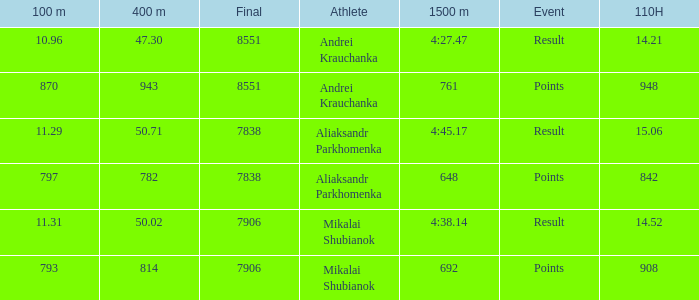Parse the table in full. {'header': ['100 m', '400 m', 'Final', 'Athlete', '1500 m', 'Event', '110H'], 'rows': [['10.96', '47.30', '8551', 'Andrei Krauchanka', '4:27.47', 'Result', '14.21'], ['870', '943', '8551', 'Andrei Krauchanka', '761', 'Points', '948'], ['11.29', '50.71', '7838', 'Aliaksandr Parkhomenka', '4:45.17', 'Result', '15.06'], ['797', '782', '7838', 'Aliaksandr Parkhomenka', '648', 'Points', '842'], ['11.31', '50.02', '7906', 'Mikalai Shubianok', '4:38.14', 'Result', '14.52'], ['793', '814', '7906', 'Mikalai Shubianok', '692', 'Points', '908']]} What was the 400m that had a 110H greater than 14.21, a final of more than 7838, and having result in events? 1.0. 